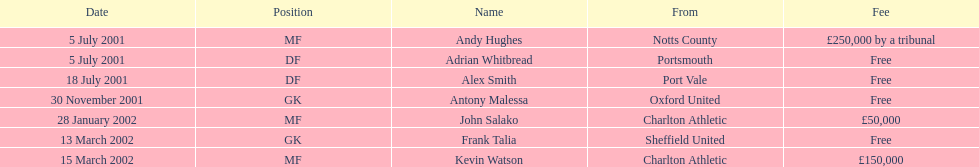Who transferred after 30 november 2001? John Salako, Frank Talia, Kevin Watson. 